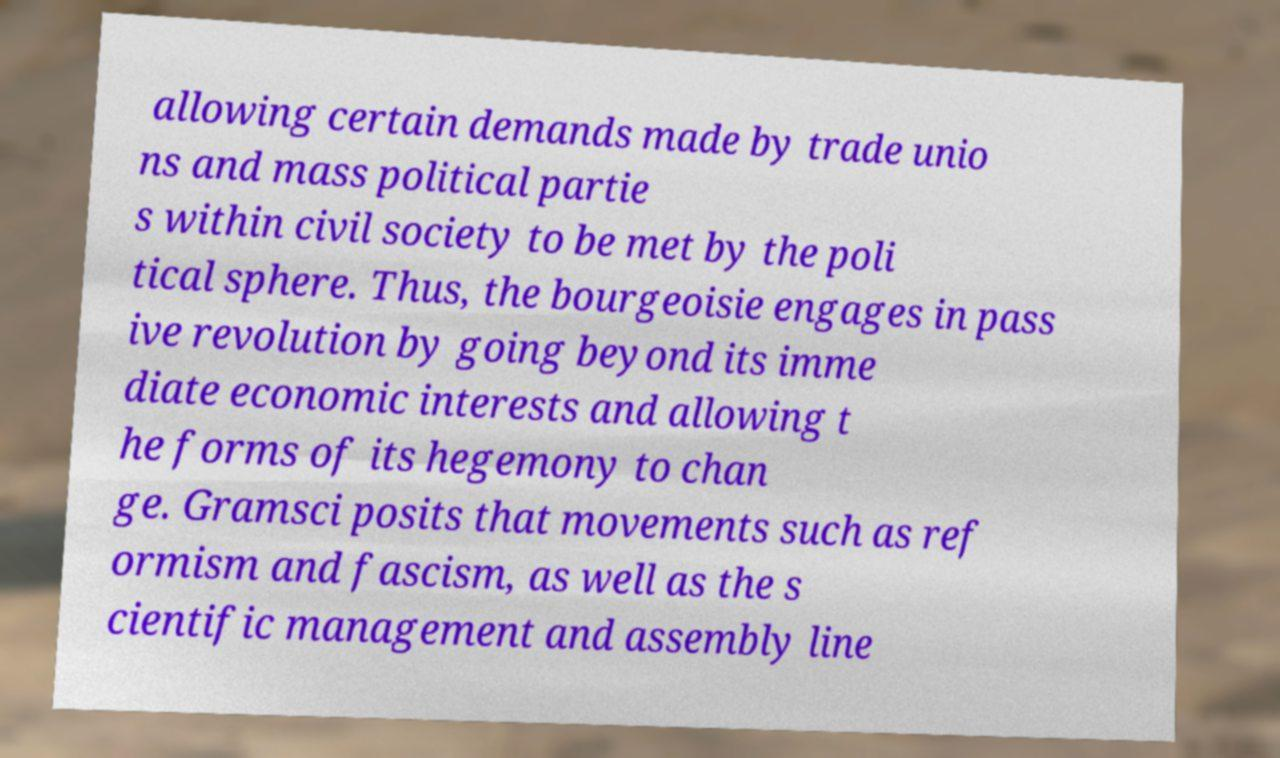I need the written content from this picture converted into text. Can you do that? allowing certain demands made by trade unio ns and mass political partie s within civil society to be met by the poli tical sphere. Thus, the bourgeoisie engages in pass ive revolution by going beyond its imme diate economic interests and allowing t he forms of its hegemony to chan ge. Gramsci posits that movements such as ref ormism and fascism, as well as the s cientific management and assembly line 